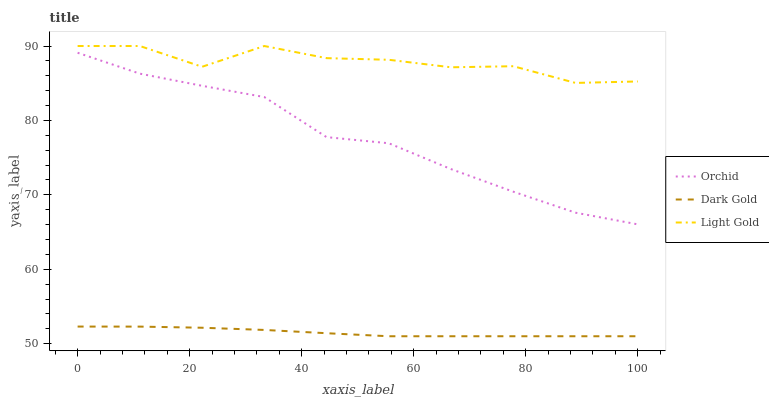Does Dark Gold have the minimum area under the curve?
Answer yes or no. Yes. Does Light Gold have the maximum area under the curve?
Answer yes or no. Yes. Does Orchid have the minimum area under the curve?
Answer yes or no. No. Does Orchid have the maximum area under the curve?
Answer yes or no. No. Is Dark Gold the smoothest?
Answer yes or no. Yes. Is Light Gold the roughest?
Answer yes or no. Yes. Is Orchid the smoothest?
Answer yes or no. No. Is Orchid the roughest?
Answer yes or no. No. Does Orchid have the lowest value?
Answer yes or no. No. Does Orchid have the highest value?
Answer yes or no. No. Is Orchid less than Light Gold?
Answer yes or no. Yes. Is Light Gold greater than Dark Gold?
Answer yes or no. Yes. Does Orchid intersect Light Gold?
Answer yes or no. No. 